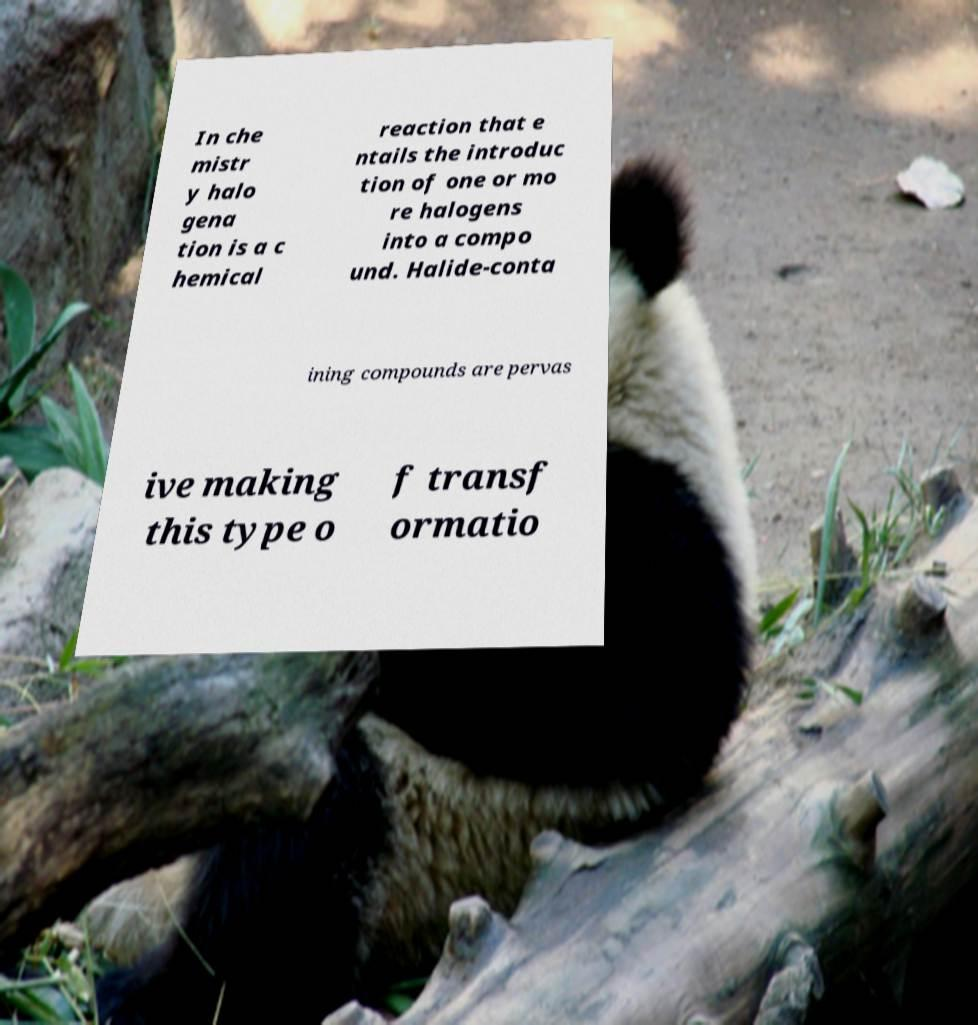I need the written content from this picture converted into text. Can you do that? In che mistr y halo gena tion is a c hemical reaction that e ntails the introduc tion of one or mo re halogens into a compo und. Halide-conta ining compounds are pervas ive making this type o f transf ormatio 